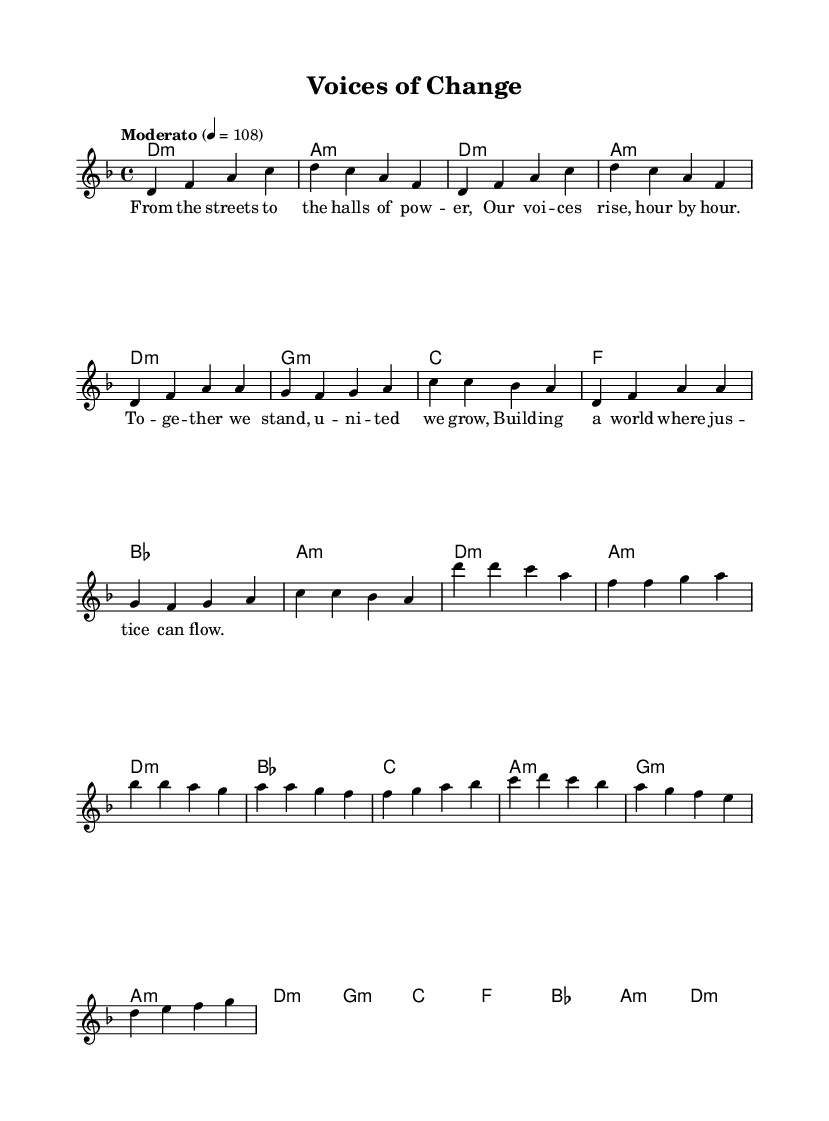What is the key signature of this music? The key signature is indicated at the beginning of the sheet music. Here, it consists of one flat, which corresponds to the key of D minor.
Answer: D minor What is the time signature of this piece? The time signature is found at the beginning of the music, represented by the numbers indicating how many beats are in a measure and which note value gets the beat. In this case, it is 4/4, meaning there are four beats per measure.
Answer: 4/4 What is the tempo marking for this composition? The tempo marking is provided at the beginning of the sheet music, specifying the speed of the piece. It states "Moderato" followed by the metronome marking 4 = 108, indicating a moderate speed.
Answer: Moderato, 108 How many measures are in the chorus section? To find this, we need to count the measures in the chorus section explicitly indicated in the sheet music. The chorus has a total of 7 measures.
Answer: 7 What is the emotional theme presented in the lyrics? The lyrics focus on themes of empowerment, unity, and social justice, reflecting grassroots activism. Analyzing the words suggests a call for collective action and hope for a just society.
Answer: Empowerment How many different chord types are used in the music? A close look at the chord progression reveals a variety of chord types such as minor and major chords. Specifically, the music uses five types of chords throughout its sections.
Answer: Five What message do the lyrics convey about community? By examining the lyrical content, it is apparent that the message emphasizes unity and collective strength among individuals to foster change. The lyrics suggest that togetherness leads to empowerment.
Answer: Unity 